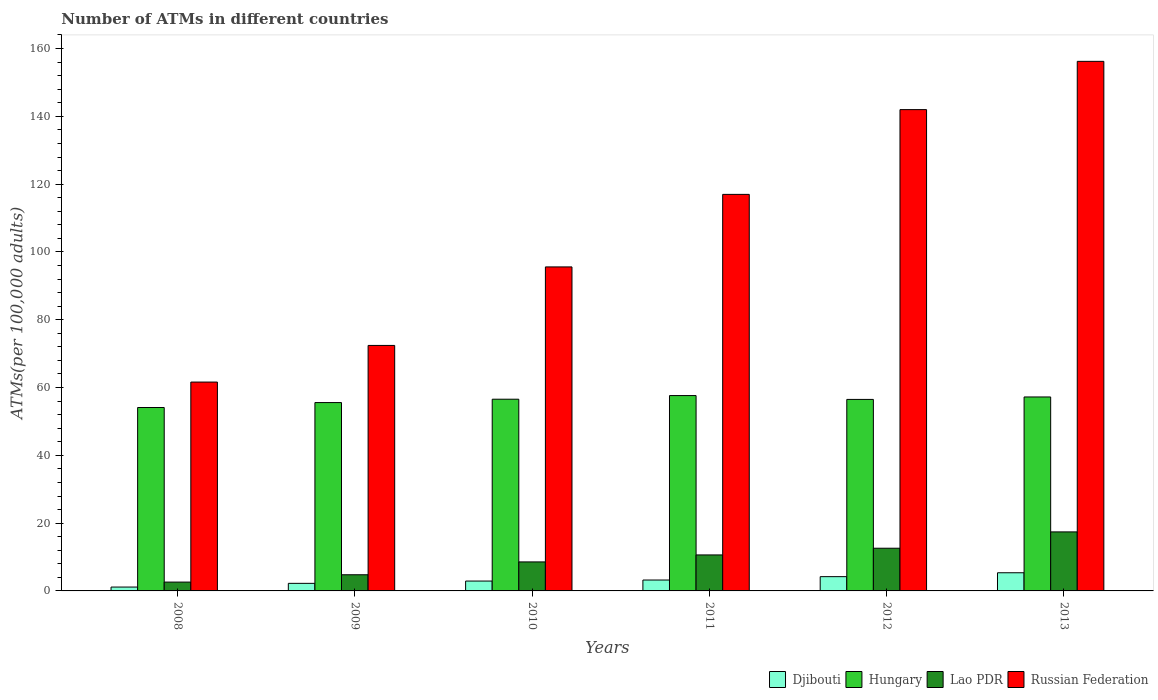How many different coloured bars are there?
Keep it short and to the point. 4. How many bars are there on the 6th tick from the left?
Your answer should be compact. 4. How many bars are there on the 4th tick from the right?
Your answer should be very brief. 4. What is the label of the 2nd group of bars from the left?
Your answer should be very brief. 2009. What is the number of ATMs in Lao PDR in 2011?
Your response must be concise. 10.62. Across all years, what is the maximum number of ATMs in Lao PDR?
Ensure brevity in your answer.  17.41. Across all years, what is the minimum number of ATMs in Hungary?
Ensure brevity in your answer.  54.1. In which year was the number of ATMs in Lao PDR maximum?
Make the answer very short. 2013. What is the total number of ATMs in Lao PDR in the graph?
Your response must be concise. 56.55. What is the difference between the number of ATMs in Russian Federation in 2009 and that in 2010?
Ensure brevity in your answer.  -23.16. What is the difference between the number of ATMs in Lao PDR in 2010 and the number of ATMs in Russian Federation in 2009?
Ensure brevity in your answer.  -63.86. What is the average number of ATMs in Hungary per year?
Make the answer very short. 56.26. In the year 2012, what is the difference between the number of ATMs in Lao PDR and number of ATMs in Russian Federation?
Offer a very short reply. -129.39. What is the ratio of the number of ATMs in Lao PDR in 2008 to that in 2009?
Give a very brief answer. 0.55. Is the difference between the number of ATMs in Lao PDR in 2010 and 2012 greater than the difference between the number of ATMs in Russian Federation in 2010 and 2012?
Make the answer very short. Yes. What is the difference between the highest and the second highest number of ATMs in Russian Federation?
Give a very brief answer. 14.24. What is the difference between the highest and the lowest number of ATMs in Lao PDR?
Provide a short and direct response. 14.8. In how many years, is the number of ATMs in Lao PDR greater than the average number of ATMs in Lao PDR taken over all years?
Provide a short and direct response. 3. Is the sum of the number of ATMs in Lao PDR in 2010 and 2011 greater than the maximum number of ATMs in Djibouti across all years?
Provide a short and direct response. Yes. Is it the case that in every year, the sum of the number of ATMs in Lao PDR and number of ATMs in Russian Federation is greater than the sum of number of ATMs in Djibouti and number of ATMs in Hungary?
Offer a very short reply. No. What does the 2nd bar from the left in 2011 represents?
Keep it short and to the point. Hungary. What does the 1st bar from the right in 2008 represents?
Make the answer very short. Russian Federation. How many bars are there?
Your answer should be compact. 24. How are the legend labels stacked?
Give a very brief answer. Horizontal. What is the title of the graph?
Your answer should be very brief. Number of ATMs in different countries. What is the label or title of the Y-axis?
Provide a short and direct response. ATMs(per 100,0 adults). What is the ATMs(per 100,000 adults) of Djibouti in 2008?
Ensure brevity in your answer.  1.14. What is the ATMs(per 100,000 adults) in Hungary in 2008?
Provide a succinct answer. 54.1. What is the ATMs(per 100,000 adults) in Lao PDR in 2008?
Keep it short and to the point. 2.61. What is the ATMs(per 100,000 adults) in Russian Federation in 2008?
Give a very brief answer. 61.61. What is the ATMs(per 100,000 adults) of Djibouti in 2009?
Provide a short and direct response. 2.23. What is the ATMs(per 100,000 adults) of Hungary in 2009?
Your answer should be very brief. 55.56. What is the ATMs(per 100,000 adults) of Lao PDR in 2009?
Provide a succinct answer. 4.77. What is the ATMs(per 100,000 adults) in Russian Federation in 2009?
Ensure brevity in your answer.  72.42. What is the ATMs(per 100,000 adults) of Djibouti in 2010?
Your response must be concise. 2.91. What is the ATMs(per 100,000 adults) of Hungary in 2010?
Keep it short and to the point. 56.55. What is the ATMs(per 100,000 adults) of Lao PDR in 2010?
Provide a short and direct response. 8.56. What is the ATMs(per 100,000 adults) in Russian Federation in 2010?
Offer a very short reply. 95.58. What is the ATMs(per 100,000 adults) of Djibouti in 2011?
Provide a short and direct response. 3.21. What is the ATMs(per 100,000 adults) of Hungary in 2011?
Provide a short and direct response. 57.63. What is the ATMs(per 100,000 adults) in Lao PDR in 2011?
Provide a succinct answer. 10.62. What is the ATMs(per 100,000 adults) in Russian Federation in 2011?
Make the answer very short. 116.98. What is the ATMs(per 100,000 adults) in Djibouti in 2012?
Provide a succinct answer. 4.21. What is the ATMs(per 100,000 adults) of Hungary in 2012?
Give a very brief answer. 56.49. What is the ATMs(per 100,000 adults) of Lao PDR in 2012?
Your answer should be very brief. 12.59. What is the ATMs(per 100,000 adults) in Russian Federation in 2012?
Offer a terse response. 141.98. What is the ATMs(per 100,000 adults) of Djibouti in 2013?
Your response must be concise. 5.36. What is the ATMs(per 100,000 adults) of Hungary in 2013?
Offer a terse response. 57.22. What is the ATMs(per 100,000 adults) in Lao PDR in 2013?
Make the answer very short. 17.41. What is the ATMs(per 100,000 adults) in Russian Federation in 2013?
Your answer should be compact. 156.22. Across all years, what is the maximum ATMs(per 100,000 adults) of Djibouti?
Keep it short and to the point. 5.36. Across all years, what is the maximum ATMs(per 100,000 adults) of Hungary?
Your answer should be compact. 57.63. Across all years, what is the maximum ATMs(per 100,000 adults) of Lao PDR?
Make the answer very short. 17.41. Across all years, what is the maximum ATMs(per 100,000 adults) of Russian Federation?
Give a very brief answer. 156.22. Across all years, what is the minimum ATMs(per 100,000 adults) in Djibouti?
Give a very brief answer. 1.14. Across all years, what is the minimum ATMs(per 100,000 adults) in Hungary?
Your answer should be very brief. 54.1. Across all years, what is the minimum ATMs(per 100,000 adults) in Lao PDR?
Your response must be concise. 2.61. Across all years, what is the minimum ATMs(per 100,000 adults) of Russian Federation?
Your answer should be compact. 61.61. What is the total ATMs(per 100,000 adults) in Djibouti in the graph?
Give a very brief answer. 19.07. What is the total ATMs(per 100,000 adults) of Hungary in the graph?
Make the answer very short. 337.55. What is the total ATMs(per 100,000 adults) of Lao PDR in the graph?
Your response must be concise. 56.55. What is the total ATMs(per 100,000 adults) of Russian Federation in the graph?
Keep it short and to the point. 644.78. What is the difference between the ATMs(per 100,000 adults) in Djibouti in 2008 and that in 2009?
Your answer should be very brief. -1.09. What is the difference between the ATMs(per 100,000 adults) of Hungary in 2008 and that in 2009?
Provide a succinct answer. -1.46. What is the difference between the ATMs(per 100,000 adults) in Lao PDR in 2008 and that in 2009?
Offer a terse response. -2.16. What is the difference between the ATMs(per 100,000 adults) of Russian Federation in 2008 and that in 2009?
Your response must be concise. -10.81. What is the difference between the ATMs(per 100,000 adults) in Djibouti in 2008 and that in 2010?
Keep it short and to the point. -1.77. What is the difference between the ATMs(per 100,000 adults) of Hungary in 2008 and that in 2010?
Your answer should be compact. -2.45. What is the difference between the ATMs(per 100,000 adults) of Lao PDR in 2008 and that in 2010?
Offer a very short reply. -5.95. What is the difference between the ATMs(per 100,000 adults) of Russian Federation in 2008 and that in 2010?
Make the answer very short. -33.97. What is the difference between the ATMs(per 100,000 adults) in Djibouti in 2008 and that in 2011?
Keep it short and to the point. -2.07. What is the difference between the ATMs(per 100,000 adults) of Hungary in 2008 and that in 2011?
Give a very brief answer. -3.52. What is the difference between the ATMs(per 100,000 adults) in Lao PDR in 2008 and that in 2011?
Provide a succinct answer. -8.01. What is the difference between the ATMs(per 100,000 adults) in Russian Federation in 2008 and that in 2011?
Provide a short and direct response. -55.36. What is the difference between the ATMs(per 100,000 adults) of Djibouti in 2008 and that in 2012?
Your response must be concise. -3.07. What is the difference between the ATMs(per 100,000 adults) of Hungary in 2008 and that in 2012?
Ensure brevity in your answer.  -2.39. What is the difference between the ATMs(per 100,000 adults) in Lao PDR in 2008 and that in 2012?
Ensure brevity in your answer.  -9.99. What is the difference between the ATMs(per 100,000 adults) of Russian Federation in 2008 and that in 2012?
Keep it short and to the point. -80.37. What is the difference between the ATMs(per 100,000 adults) of Djibouti in 2008 and that in 2013?
Keep it short and to the point. -4.22. What is the difference between the ATMs(per 100,000 adults) in Hungary in 2008 and that in 2013?
Ensure brevity in your answer.  -3.11. What is the difference between the ATMs(per 100,000 adults) of Lao PDR in 2008 and that in 2013?
Offer a very short reply. -14.8. What is the difference between the ATMs(per 100,000 adults) of Russian Federation in 2008 and that in 2013?
Ensure brevity in your answer.  -94.61. What is the difference between the ATMs(per 100,000 adults) of Djibouti in 2009 and that in 2010?
Give a very brief answer. -0.68. What is the difference between the ATMs(per 100,000 adults) in Hungary in 2009 and that in 2010?
Your response must be concise. -0.99. What is the difference between the ATMs(per 100,000 adults) in Lao PDR in 2009 and that in 2010?
Make the answer very short. -3.79. What is the difference between the ATMs(per 100,000 adults) of Russian Federation in 2009 and that in 2010?
Make the answer very short. -23.16. What is the difference between the ATMs(per 100,000 adults) in Djibouti in 2009 and that in 2011?
Your answer should be compact. -0.98. What is the difference between the ATMs(per 100,000 adults) of Hungary in 2009 and that in 2011?
Give a very brief answer. -2.07. What is the difference between the ATMs(per 100,000 adults) in Lao PDR in 2009 and that in 2011?
Provide a succinct answer. -5.85. What is the difference between the ATMs(per 100,000 adults) in Russian Federation in 2009 and that in 2011?
Provide a succinct answer. -44.56. What is the difference between the ATMs(per 100,000 adults) of Djibouti in 2009 and that in 2012?
Ensure brevity in your answer.  -1.98. What is the difference between the ATMs(per 100,000 adults) in Hungary in 2009 and that in 2012?
Make the answer very short. -0.93. What is the difference between the ATMs(per 100,000 adults) in Lao PDR in 2009 and that in 2012?
Your response must be concise. -7.83. What is the difference between the ATMs(per 100,000 adults) in Russian Federation in 2009 and that in 2012?
Offer a terse response. -69.56. What is the difference between the ATMs(per 100,000 adults) in Djibouti in 2009 and that in 2013?
Ensure brevity in your answer.  -3.13. What is the difference between the ATMs(per 100,000 adults) of Hungary in 2009 and that in 2013?
Offer a terse response. -1.66. What is the difference between the ATMs(per 100,000 adults) in Lao PDR in 2009 and that in 2013?
Make the answer very short. -12.64. What is the difference between the ATMs(per 100,000 adults) of Russian Federation in 2009 and that in 2013?
Make the answer very short. -83.8. What is the difference between the ATMs(per 100,000 adults) of Djibouti in 2010 and that in 2011?
Keep it short and to the point. -0.3. What is the difference between the ATMs(per 100,000 adults) in Hungary in 2010 and that in 2011?
Provide a short and direct response. -1.08. What is the difference between the ATMs(per 100,000 adults) in Lao PDR in 2010 and that in 2011?
Keep it short and to the point. -2.06. What is the difference between the ATMs(per 100,000 adults) in Russian Federation in 2010 and that in 2011?
Offer a very short reply. -21.4. What is the difference between the ATMs(per 100,000 adults) in Djibouti in 2010 and that in 2012?
Your response must be concise. -1.3. What is the difference between the ATMs(per 100,000 adults) in Hungary in 2010 and that in 2012?
Offer a very short reply. 0.06. What is the difference between the ATMs(per 100,000 adults) in Lao PDR in 2010 and that in 2012?
Keep it short and to the point. -4.04. What is the difference between the ATMs(per 100,000 adults) in Russian Federation in 2010 and that in 2012?
Provide a succinct answer. -46.4. What is the difference between the ATMs(per 100,000 adults) in Djibouti in 2010 and that in 2013?
Provide a short and direct response. -2.44. What is the difference between the ATMs(per 100,000 adults) in Hungary in 2010 and that in 2013?
Your answer should be compact. -0.67. What is the difference between the ATMs(per 100,000 adults) of Lao PDR in 2010 and that in 2013?
Your answer should be compact. -8.86. What is the difference between the ATMs(per 100,000 adults) in Russian Federation in 2010 and that in 2013?
Offer a terse response. -60.64. What is the difference between the ATMs(per 100,000 adults) in Djibouti in 2011 and that in 2012?
Provide a succinct answer. -1. What is the difference between the ATMs(per 100,000 adults) in Hungary in 2011 and that in 2012?
Your answer should be very brief. 1.13. What is the difference between the ATMs(per 100,000 adults) in Lao PDR in 2011 and that in 2012?
Your response must be concise. -1.98. What is the difference between the ATMs(per 100,000 adults) in Russian Federation in 2011 and that in 2012?
Ensure brevity in your answer.  -25.01. What is the difference between the ATMs(per 100,000 adults) in Djibouti in 2011 and that in 2013?
Make the answer very short. -2.14. What is the difference between the ATMs(per 100,000 adults) of Hungary in 2011 and that in 2013?
Your response must be concise. 0.41. What is the difference between the ATMs(per 100,000 adults) of Lao PDR in 2011 and that in 2013?
Ensure brevity in your answer.  -6.79. What is the difference between the ATMs(per 100,000 adults) in Russian Federation in 2011 and that in 2013?
Offer a very short reply. -39.24. What is the difference between the ATMs(per 100,000 adults) of Djibouti in 2012 and that in 2013?
Your response must be concise. -1.14. What is the difference between the ATMs(per 100,000 adults) in Hungary in 2012 and that in 2013?
Your answer should be compact. -0.72. What is the difference between the ATMs(per 100,000 adults) in Lao PDR in 2012 and that in 2013?
Provide a short and direct response. -4.82. What is the difference between the ATMs(per 100,000 adults) of Russian Federation in 2012 and that in 2013?
Keep it short and to the point. -14.24. What is the difference between the ATMs(per 100,000 adults) in Djibouti in 2008 and the ATMs(per 100,000 adults) in Hungary in 2009?
Ensure brevity in your answer.  -54.42. What is the difference between the ATMs(per 100,000 adults) of Djibouti in 2008 and the ATMs(per 100,000 adults) of Lao PDR in 2009?
Provide a short and direct response. -3.63. What is the difference between the ATMs(per 100,000 adults) of Djibouti in 2008 and the ATMs(per 100,000 adults) of Russian Federation in 2009?
Ensure brevity in your answer.  -71.28. What is the difference between the ATMs(per 100,000 adults) of Hungary in 2008 and the ATMs(per 100,000 adults) of Lao PDR in 2009?
Give a very brief answer. 49.34. What is the difference between the ATMs(per 100,000 adults) in Hungary in 2008 and the ATMs(per 100,000 adults) in Russian Federation in 2009?
Offer a terse response. -18.31. What is the difference between the ATMs(per 100,000 adults) of Lao PDR in 2008 and the ATMs(per 100,000 adults) of Russian Federation in 2009?
Offer a very short reply. -69.81. What is the difference between the ATMs(per 100,000 adults) of Djibouti in 2008 and the ATMs(per 100,000 adults) of Hungary in 2010?
Offer a very short reply. -55.41. What is the difference between the ATMs(per 100,000 adults) of Djibouti in 2008 and the ATMs(per 100,000 adults) of Lao PDR in 2010?
Your answer should be compact. -7.41. What is the difference between the ATMs(per 100,000 adults) of Djibouti in 2008 and the ATMs(per 100,000 adults) of Russian Federation in 2010?
Make the answer very short. -94.44. What is the difference between the ATMs(per 100,000 adults) in Hungary in 2008 and the ATMs(per 100,000 adults) in Lao PDR in 2010?
Your answer should be very brief. 45.55. What is the difference between the ATMs(per 100,000 adults) of Hungary in 2008 and the ATMs(per 100,000 adults) of Russian Federation in 2010?
Offer a very short reply. -41.47. What is the difference between the ATMs(per 100,000 adults) in Lao PDR in 2008 and the ATMs(per 100,000 adults) in Russian Federation in 2010?
Your answer should be very brief. -92.97. What is the difference between the ATMs(per 100,000 adults) of Djibouti in 2008 and the ATMs(per 100,000 adults) of Hungary in 2011?
Provide a succinct answer. -56.49. What is the difference between the ATMs(per 100,000 adults) of Djibouti in 2008 and the ATMs(per 100,000 adults) of Lao PDR in 2011?
Your answer should be very brief. -9.48. What is the difference between the ATMs(per 100,000 adults) of Djibouti in 2008 and the ATMs(per 100,000 adults) of Russian Federation in 2011?
Ensure brevity in your answer.  -115.83. What is the difference between the ATMs(per 100,000 adults) in Hungary in 2008 and the ATMs(per 100,000 adults) in Lao PDR in 2011?
Offer a terse response. 43.49. What is the difference between the ATMs(per 100,000 adults) of Hungary in 2008 and the ATMs(per 100,000 adults) of Russian Federation in 2011?
Offer a very short reply. -62.87. What is the difference between the ATMs(per 100,000 adults) of Lao PDR in 2008 and the ATMs(per 100,000 adults) of Russian Federation in 2011?
Make the answer very short. -114.37. What is the difference between the ATMs(per 100,000 adults) in Djibouti in 2008 and the ATMs(per 100,000 adults) in Hungary in 2012?
Give a very brief answer. -55.35. What is the difference between the ATMs(per 100,000 adults) of Djibouti in 2008 and the ATMs(per 100,000 adults) of Lao PDR in 2012?
Keep it short and to the point. -11.45. What is the difference between the ATMs(per 100,000 adults) in Djibouti in 2008 and the ATMs(per 100,000 adults) in Russian Federation in 2012?
Your answer should be very brief. -140.84. What is the difference between the ATMs(per 100,000 adults) in Hungary in 2008 and the ATMs(per 100,000 adults) in Lao PDR in 2012?
Make the answer very short. 41.51. What is the difference between the ATMs(per 100,000 adults) of Hungary in 2008 and the ATMs(per 100,000 adults) of Russian Federation in 2012?
Make the answer very short. -87.88. What is the difference between the ATMs(per 100,000 adults) of Lao PDR in 2008 and the ATMs(per 100,000 adults) of Russian Federation in 2012?
Offer a very short reply. -139.37. What is the difference between the ATMs(per 100,000 adults) of Djibouti in 2008 and the ATMs(per 100,000 adults) of Hungary in 2013?
Provide a succinct answer. -56.08. What is the difference between the ATMs(per 100,000 adults) of Djibouti in 2008 and the ATMs(per 100,000 adults) of Lao PDR in 2013?
Give a very brief answer. -16.27. What is the difference between the ATMs(per 100,000 adults) of Djibouti in 2008 and the ATMs(per 100,000 adults) of Russian Federation in 2013?
Provide a succinct answer. -155.08. What is the difference between the ATMs(per 100,000 adults) of Hungary in 2008 and the ATMs(per 100,000 adults) of Lao PDR in 2013?
Provide a short and direct response. 36.69. What is the difference between the ATMs(per 100,000 adults) in Hungary in 2008 and the ATMs(per 100,000 adults) in Russian Federation in 2013?
Ensure brevity in your answer.  -102.11. What is the difference between the ATMs(per 100,000 adults) in Lao PDR in 2008 and the ATMs(per 100,000 adults) in Russian Federation in 2013?
Provide a short and direct response. -153.61. What is the difference between the ATMs(per 100,000 adults) in Djibouti in 2009 and the ATMs(per 100,000 adults) in Hungary in 2010?
Keep it short and to the point. -54.32. What is the difference between the ATMs(per 100,000 adults) in Djibouti in 2009 and the ATMs(per 100,000 adults) in Lao PDR in 2010?
Offer a very short reply. -6.33. What is the difference between the ATMs(per 100,000 adults) of Djibouti in 2009 and the ATMs(per 100,000 adults) of Russian Federation in 2010?
Your answer should be very brief. -93.35. What is the difference between the ATMs(per 100,000 adults) of Hungary in 2009 and the ATMs(per 100,000 adults) of Lao PDR in 2010?
Provide a short and direct response. 47. What is the difference between the ATMs(per 100,000 adults) in Hungary in 2009 and the ATMs(per 100,000 adults) in Russian Federation in 2010?
Offer a terse response. -40.02. What is the difference between the ATMs(per 100,000 adults) in Lao PDR in 2009 and the ATMs(per 100,000 adults) in Russian Federation in 2010?
Make the answer very short. -90.81. What is the difference between the ATMs(per 100,000 adults) in Djibouti in 2009 and the ATMs(per 100,000 adults) in Hungary in 2011?
Give a very brief answer. -55.4. What is the difference between the ATMs(per 100,000 adults) in Djibouti in 2009 and the ATMs(per 100,000 adults) in Lao PDR in 2011?
Provide a succinct answer. -8.39. What is the difference between the ATMs(per 100,000 adults) in Djibouti in 2009 and the ATMs(per 100,000 adults) in Russian Federation in 2011?
Give a very brief answer. -114.75. What is the difference between the ATMs(per 100,000 adults) in Hungary in 2009 and the ATMs(per 100,000 adults) in Lao PDR in 2011?
Your answer should be very brief. 44.94. What is the difference between the ATMs(per 100,000 adults) in Hungary in 2009 and the ATMs(per 100,000 adults) in Russian Federation in 2011?
Provide a succinct answer. -61.42. What is the difference between the ATMs(per 100,000 adults) of Lao PDR in 2009 and the ATMs(per 100,000 adults) of Russian Federation in 2011?
Offer a very short reply. -112.21. What is the difference between the ATMs(per 100,000 adults) in Djibouti in 2009 and the ATMs(per 100,000 adults) in Hungary in 2012?
Your response must be concise. -54.26. What is the difference between the ATMs(per 100,000 adults) in Djibouti in 2009 and the ATMs(per 100,000 adults) in Lao PDR in 2012?
Offer a terse response. -10.36. What is the difference between the ATMs(per 100,000 adults) of Djibouti in 2009 and the ATMs(per 100,000 adults) of Russian Federation in 2012?
Make the answer very short. -139.75. What is the difference between the ATMs(per 100,000 adults) in Hungary in 2009 and the ATMs(per 100,000 adults) in Lao PDR in 2012?
Offer a terse response. 42.97. What is the difference between the ATMs(per 100,000 adults) in Hungary in 2009 and the ATMs(per 100,000 adults) in Russian Federation in 2012?
Your answer should be very brief. -86.42. What is the difference between the ATMs(per 100,000 adults) in Lao PDR in 2009 and the ATMs(per 100,000 adults) in Russian Federation in 2012?
Your response must be concise. -137.21. What is the difference between the ATMs(per 100,000 adults) of Djibouti in 2009 and the ATMs(per 100,000 adults) of Hungary in 2013?
Provide a short and direct response. -54.99. What is the difference between the ATMs(per 100,000 adults) in Djibouti in 2009 and the ATMs(per 100,000 adults) in Lao PDR in 2013?
Give a very brief answer. -15.18. What is the difference between the ATMs(per 100,000 adults) of Djibouti in 2009 and the ATMs(per 100,000 adults) of Russian Federation in 2013?
Give a very brief answer. -153.99. What is the difference between the ATMs(per 100,000 adults) of Hungary in 2009 and the ATMs(per 100,000 adults) of Lao PDR in 2013?
Offer a very short reply. 38.15. What is the difference between the ATMs(per 100,000 adults) of Hungary in 2009 and the ATMs(per 100,000 adults) of Russian Federation in 2013?
Offer a terse response. -100.66. What is the difference between the ATMs(per 100,000 adults) of Lao PDR in 2009 and the ATMs(per 100,000 adults) of Russian Federation in 2013?
Your answer should be very brief. -151.45. What is the difference between the ATMs(per 100,000 adults) of Djibouti in 2010 and the ATMs(per 100,000 adults) of Hungary in 2011?
Offer a very short reply. -54.71. What is the difference between the ATMs(per 100,000 adults) in Djibouti in 2010 and the ATMs(per 100,000 adults) in Lao PDR in 2011?
Give a very brief answer. -7.7. What is the difference between the ATMs(per 100,000 adults) in Djibouti in 2010 and the ATMs(per 100,000 adults) in Russian Federation in 2011?
Keep it short and to the point. -114.06. What is the difference between the ATMs(per 100,000 adults) in Hungary in 2010 and the ATMs(per 100,000 adults) in Lao PDR in 2011?
Provide a succinct answer. 45.93. What is the difference between the ATMs(per 100,000 adults) of Hungary in 2010 and the ATMs(per 100,000 adults) of Russian Federation in 2011?
Provide a succinct answer. -60.42. What is the difference between the ATMs(per 100,000 adults) of Lao PDR in 2010 and the ATMs(per 100,000 adults) of Russian Federation in 2011?
Your answer should be very brief. -108.42. What is the difference between the ATMs(per 100,000 adults) of Djibouti in 2010 and the ATMs(per 100,000 adults) of Hungary in 2012?
Your answer should be compact. -53.58. What is the difference between the ATMs(per 100,000 adults) in Djibouti in 2010 and the ATMs(per 100,000 adults) in Lao PDR in 2012?
Offer a very short reply. -9.68. What is the difference between the ATMs(per 100,000 adults) of Djibouti in 2010 and the ATMs(per 100,000 adults) of Russian Federation in 2012?
Offer a very short reply. -139.07. What is the difference between the ATMs(per 100,000 adults) in Hungary in 2010 and the ATMs(per 100,000 adults) in Lao PDR in 2012?
Offer a terse response. 43.96. What is the difference between the ATMs(per 100,000 adults) in Hungary in 2010 and the ATMs(per 100,000 adults) in Russian Federation in 2012?
Your answer should be compact. -85.43. What is the difference between the ATMs(per 100,000 adults) of Lao PDR in 2010 and the ATMs(per 100,000 adults) of Russian Federation in 2012?
Offer a terse response. -133.43. What is the difference between the ATMs(per 100,000 adults) in Djibouti in 2010 and the ATMs(per 100,000 adults) in Hungary in 2013?
Your answer should be compact. -54.3. What is the difference between the ATMs(per 100,000 adults) of Djibouti in 2010 and the ATMs(per 100,000 adults) of Lao PDR in 2013?
Provide a short and direct response. -14.5. What is the difference between the ATMs(per 100,000 adults) in Djibouti in 2010 and the ATMs(per 100,000 adults) in Russian Federation in 2013?
Ensure brevity in your answer.  -153.31. What is the difference between the ATMs(per 100,000 adults) in Hungary in 2010 and the ATMs(per 100,000 adults) in Lao PDR in 2013?
Provide a short and direct response. 39.14. What is the difference between the ATMs(per 100,000 adults) of Hungary in 2010 and the ATMs(per 100,000 adults) of Russian Federation in 2013?
Provide a succinct answer. -99.67. What is the difference between the ATMs(per 100,000 adults) in Lao PDR in 2010 and the ATMs(per 100,000 adults) in Russian Federation in 2013?
Offer a very short reply. -147.66. What is the difference between the ATMs(per 100,000 adults) of Djibouti in 2011 and the ATMs(per 100,000 adults) of Hungary in 2012?
Offer a very short reply. -53.28. What is the difference between the ATMs(per 100,000 adults) of Djibouti in 2011 and the ATMs(per 100,000 adults) of Lao PDR in 2012?
Offer a terse response. -9.38. What is the difference between the ATMs(per 100,000 adults) in Djibouti in 2011 and the ATMs(per 100,000 adults) in Russian Federation in 2012?
Keep it short and to the point. -138.77. What is the difference between the ATMs(per 100,000 adults) of Hungary in 2011 and the ATMs(per 100,000 adults) of Lao PDR in 2012?
Provide a short and direct response. 45.03. What is the difference between the ATMs(per 100,000 adults) in Hungary in 2011 and the ATMs(per 100,000 adults) in Russian Federation in 2012?
Provide a short and direct response. -84.35. What is the difference between the ATMs(per 100,000 adults) in Lao PDR in 2011 and the ATMs(per 100,000 adults) in Russian Federation in 2012?
Make the answer very short. -131.36. What is the difference between the ATMs(per 100,000 adults) in Djibouti in 2011 and the ATMs(per 100,000 adults) in Hungary in 2013?
Ensure brevity in your answer.  -54. What is the difference between the ATMs(per 100,000 adults) in Djibouti in 2011 and the ATMs(per 100,000 adults) in Lao PDR in 2013?
Your answer should be compact. -14.2. What is the difference between the ATMs(per 100,000 adults) of Djibouti in 2011 and the ATMs(per 100,000 adults) of Russian Federation in 2013?
Offer a terse response. -153. What is the difference between the ATMs(per 100,000 adults) in Hungary in 2011 and the ATMs(per 100,000 adults) in Lao PDR in 2013?
Provide a short and direct response. 40.22. What is the difference between the ATMs(per 100,000 adults) in Hungary in 2011 and the ATMs(per 100,000 adults) in Russian Federation in 2013?
Offer a terse response. -98.59. What is the difference between the ATMs(per 100,000 adults) in Lao PDR in 2011 and the ATMs(per 100,000 adults) in Russian Federation in 2013?
Give a very brief answer. -145.6. What is the difference between the ATMs(per 100,000 adults) of Djibouti in 2012 and the ATMs(per 100,000 adults) of Hungary in 2013?
Offer a very short reply. -53. What is the difference between the ATMs(per 100,000 adults) of Djibouti in 2012 and the ATMs(per 100,000 adults) of Lao PDR in 2013?
Your answer should be compact. -13.2. What is the difference between the ATMs(per 100,000 adults) of Djibouti in 2012 and the ATMs(per 100,000 adults) of Russian Federation in 2013?
Your response must be concise. -152.01. What is the difference between the ATMs(per 100,000 adults) in Hungary in 2012 and the ATMs(per 100,000 adults) in Lao PDR in 2013?
Provide a short and direct response. 39.08. What is the difference between the ATMs(per 100,000 adults) in Hungary in 2012 and the ATMs(per 100,000 adults) in Russian Federation in 2013?
Make the answer very short. -99.72. What is the difference between the ATMs(per 100,000 adults) in Lao PDR in 2012 and the ATMs(per 100,000 adults) in Russian Federation in 2013?
Give a very brief answer. -143.62. What is the average ATMs(per 100,000 adults) in Djibouti per year?
Keep it short and to the point. 3.18. What is the average ATMs(per 100,000 adults) in Hungary per year?
Offer a terse response. 56.26. What is the average ATMs(per 100,000 adults) in Lao PDR per year?
Your answer should be compact. 9.43. What is the average ATMs(per 100,000 adults) of Russian Federation per year?
Provide a short and direct response. 107.46. In the year 2008, what is the difference between the ATMs(per 100,000 adults) of Djibouti and ATMs(per 100,000 adults) of Hungary?
Provide a succinct answer. -52.96. In the year 2008, what is the difference between the ATMs(per 100,000 adults) in Djibouti and ATMs(per 100,000 adults) in Lao PDR?
Offer a very short reply. -1.47. In the year 2008, what is the difference between the ATMs(per 100,000 adults) of Djibouti and ATMs(per 100,000 adults) of Russian Federation?
Your answer should be compact. -60.47. In the year 2008, what is the difference between the ATMs(per 100,000 adults) of Hungary and ATMs(per 100,000 adults) of Lao PDR?
Give a very brief answer. 51.5. In the year 2008, what is the difference between the ATMs(per 100,000 adults) in Hungary and ATMs(per 100,000 adults) in Russian Federation?
Your answer should be compact. -7.51. In the year 2008, what is the difference between the ATMs(per 100,000 adults) of Lao PDR and ATMs(per 100,000 adults) of Russian Federation?
Ensure brevity in your answer.  -59. In the year 2009, what is the difference between the ATMs(per 100,000 adults) of Djibouti and ATMs(per 100,000 adults) of Hungary?
Provide a short and direct response. -53.33. In the year 2009, what is the difference between the ATMs(per 100,000 adults) of Djibouti and ATMs(per 100,000 adults) of Lao PDR?
Your answer should be very brief. -2.54. In the year 2009, what is the difference between the ATMs(per 100,000 adults) in Djibouti and ATMs(per 100,000 adults) in Russian Federation?
Your answer should be compact. -70.19. In the year 2009, what is the difference between the ATMs(per 100,000 adults) in Hungary and ATMs(per 100,000 adults) in Lao PDR?
Provide a succinct answer. 50.79. In the year 2009, what is the difference between the ATMs(per 100,000 adults) in Hungary and ATMs(per 100,000 adults) in Russian Federation?
Provide a succinct answer. -16.86. In the year 2009, what is the difference between the ATMs(per 100,000 adults) of Lao PDR and ATMs(per 100,000 adults) of Russian Federation?
Ensure brevity in your answer.  -67.65. In the year 2010, what is the difference between the ATMs(per 100,000 adults) in Djibouti and ATMs(per 100,000 adults) in Hungary?
Offer a terse response. -53.64. In the year 2010, what is the difference between the ATMs(per 100,000 adults) in Djibouti and ATMs(per 100,000 adults) in Lao PDR?
Your answer should be compact. -5.64. In the year 2010, what is the difference between the ATMs(per 100,000 adults) in Djibouti and ATMs(per 100,000 adults) in Russian Federation?
Ensure brevity in your answer.  -92.67. In the year 2010, what is the difference between the ATMs(per 100,000 adults) of Hungary and ATMs(per 100,000 adults) of Lao PDR?
Ensure brevity in your answer.  48. In the year 2010, what is the difference between the ATMs(per 100,000 adults) of Hungary and ATMs(per 100,000 adults) of Russian Federation?
Make the answer very short. -39.03. In the year 2010, what is the difference between the ATMs(per 100,000 adults) in Lao PDR and ATMs(per 100,000 adults) in Russian Federation?
Your response must be concise. -87.02. In the year 2011, what is the difference between the ATMs(per 100,000 adults) in Djibouti and ATMs(per 100,000 adults) in Hungary?
Ensure brevity in your answer.  -54.41. In the year 2011, what is the difference between the ATMs(per 100,000 adults) in Djibouti and ATMs(per 100,000 adults) in Lao PDR?
Ensure brevity in your answer.  -7.4. In the year 2011, what is the difference between the ATMs(per 100,000 adults) of Djibouti and ATMs(per 100,000 adults) of Russian Federation?
Your answer should be compact. -113.76. In the year 2011, what is the difference between the ATMs(per 100,000 adults) in Hungary and ATMs(per 100,000 adults) in Lao PDR?
Your answer should be very brief. 47.01. In the year 2011, what is the difference between the ATMs(per 100,000 adults) of Hungary and ATMs(per 100,000 adults) of Russian Federation?
Provide a short and direct response. -59.35. In the year 2011, what is the difference between the ATMs(per 100,000 adults) of Lao PDR and ATMs(per 100,000 adults) of Russian Federation?
Provide a short and direct response. -106.36. In the year 2012, what is the difference between the ATMs(per 100,000 adults) in Djibouti and ATMs(per 100,000 adults) in Hungary?
Your response must be concise. -52.28. In the year 2012, what is the difference between the ATMs(per 100,000 adults) of Djibouti and ATMs(per 100,000 adults) of Lao PDR?
Ensure brevity in your answer.  -8.38. In the year 2012, what is the difference between the ATMs(per 100,000 adults) in Djibouti and ATMs(per 100,000 adults) in Russian Federation?
Provide a short and direct response. -137.77. In the year 2012, what is the difference between the ATMs(per 100,000 adults) in Hungary and ATMs(per 100,000 adults) in Lao PDR?
Provide a succinct answer. 43.9. In the year 2012, what is the difference between the ATMs(per 100,000 adults) in Hungary and ATMs(per 100,000 adults) in Russian Federation?
Keep it short and to the point. -85.49. In the year 2012, what is the difference between the ATMs(per 100,000 adults) in Lao PDR and ATMs(per 100,000 adults) in Russian Federation?
Offer a very short reply. -129.39. In the year 2013, what is the difference between the ATMs(per 100,000 adults) of Djibouti and ATMs(per 100,000 adults) of Hungary?
Offer a very short reply. -51.86. In the year 2013, what is the difference between the ATMs(per 100,000 adults) in Djibouti and ATMs(per 100,000 adults) in Lao PDR?
Your answer should be compact. -12.05. In the year 2013, what is the difference between the ATMs(per 100,000 adults) in Djibouti and ATMs(per 100,000 adults) in Russian Federation?
Offer a very short reply. -150.86. In the year 2013, what is the difference between the ATMs(per 100,000 adults) in Hungary and ATMs(per 100,000 adults) in Lao PDR?
Provide a short and direct response. 39.81. In the year 2013, what is the difference between the ATMs(per 100,000 adults) of Hungary and ATMs(per 100,000 adults) of Russian Federation?
Offer a very short reply. -99. In the year 2013, what is the difference between the ATMs(per 100,000 adults) of Lao PDR and ATMs(per 100,000 adults) of Russian Federation?
Provide a succinct answer. -138.81. What is the ratio of the ATMs(per 100,000 adults) of Djibouti in 2008 to that in 2009?
Make the answer very short. 0.51. What is the ratio of the ATMs(per 100,000 adults) in Hungary in 2008 to that in 2009?
Make the answer very short. 0.97. What is the ratio of the ATMs(per 100,000 adults) of Lao PDR in 2008 to that in 2009?
Provide a succinct answer. 0.55. What is the ratio of the ATMs(per 100,000 adults) of Russian Federation in 2008 to that in 2009?
Ensure brevity in your answer.  0.85. What is the ratio of the ATMs(per 100,000 adults) in Djibouti in 2008 to that in 2010?
Your answer should be compact. 0.39. What is the ratio of the ATMs(per 100,000 adults) of Hungary in 2008 to that in 2010?
Your answer should be very brief. 0.96. What is the ratio of the ATMs(per 100,000 adults) of Lao PDR in 2008 to that in 2010?
Offer a very short reply. 0.3. What is the ratio of the ATMs(per 100,000 adults) of Russian Federation in 2008 to that in 2010?
Your answer should be compact. 0.64. What is the ratio of the ATMs(per 100,000 adults) in Djibouti in 2008 to that in 2011?
Your answer should be compact. 0.35. What is the ratio of the ATMs(per 100,000 adults) of Hungary in 2008 to that in 2011?
Provide a short and direct response. 0.94. What is the ratio of the ATMs(per 100,000 adults) of Lao PDR in 2008 to that in 2011?
Provide a succinct answer. 0.25. What is the ratio of the ATMs(per 100,000 adults) of Russian Federation in 2008 to that in 2011?
Keep it short and to the point. 0.53. What is the ratio of the ATMs(per 100,000 adults) in Djibouti in 2008 to that in 2012?
Offer a terse response. 0.27. What is the ratio of the ATMs(per 100,000 adults) of Hungary in 2008 to that in 2012?
Your answer should be very brief. 0.96. What is the ratio of the ATMs(per 100,000 adults) of Lao PDR in 2008 to that in 2012?
Offer a terse response. 0.21. What is the ratio of the ATMs(per 100,000 adults) of Russian Federation in 2008 to that in 2012?
Your answer should be compact. 0.43. What is the ratio of the ATMs(per 100,000 adults) of Djibouti in 2008 to that in 2013?
Make the answer very short. 0.21. What is the ratio of the ATMs(per 100,000 adults) of Hungary in 2008 to that in 2013?
Your answer should be very brief. 0.95. What is the ratio of the ATMs(per 100,000 adults) of Lao PDR in 2008 to that in 2013?
Ensure brevity in your answer.  0.15. What is the ratio of the ATMs(per 100,000 adults) in Russian Federation in 2008 to that in 2013?
Your answer should be compact. 0.39. What is the ratio of the ATMs(per 100,000 adults) of Djibouti in 2009 to that in 2010?
Provide a short and direct response. 0.77. What is the ratio of the ATMs(per 100,000 adults) in Hungary in 2009 to that in 2010?
Give a very brief answer. 0.98. What is the ratio of the ATMs(per 100,000 adults) of Lao PDR in 2009 to that in 2010?
Offer a terse response. 0.56. What is the ratio of the ATMs(per 100,000 adults) of Russian Federation in 2009 to that in 2010?
Provide a short and direct response. 0.76. What is the ratio of the ATMs(per 100,000 adults) in Djibouti in 2009 to that in 2011?
Your answer should be very brief. 0.69. What is the ratio of the ATMs(per 100,000 adults) of Hungary in 2009 to that in 2011?
Your answer should be compact. 0.96. What is the ratio of the ATMs(per 100,000 adults) of Lao PDR in 2009 to that in 2011?
Ensure brevity in your answer.  0.45. What is the ratio of the ATMs(per 100,000 adults) in Russian Federation in 2009 to that in 2011?
Provide a succinct answer. 0.62. What is the ratio of the ATMs(per 100,000 adults) of Djibouti in 2009 to that in 2012?
Your answer should be very brief. 0.53. What is the ratio of the ATMs(per 100,000 adults) in Hungary in 2009 to that in 2012?
Your answer should be compact. 0.98. What is the ratio of the ATMs(per 100,000 adults) in Lao PDR in 2009 to that in 2012?
Offer a very short reply. 0.38. What is the ratio of the ATMs(per 100,000 adults) of Russian Federation in 2009 to that in 2012?
Keep it short and to the point. 0.51. What is the ratio of the ATMs(per 100,000 adults) of Djibouti in 2009 to that in 2013?
Your answer should be compact. 0.42. What is the ratio of the ATMs(per 100,000 adults) of Hungary in 2009 to that in 2013?
Provide a succinct answer. 0.97. What is the ratio of the ATMs(per 100,000 adults) of Lao PDR in 2009 to that in 2013?
Ensure brevity in your answer.  0.27. What is the ratio of the ATMs(per 100,000 adults) of Russian Federation in 2009 to that in 2013?
Offer a very short reply. 0.46. What is the ratio of the ATMs(per 100,000 adults) of Djibouti in 2010 to that in 2011?
Give a very brief answer. 0.91. What is the ratio of the ATMs(per 100,000 adults) in Hungary in 2010 to that in 2011?
Keep it short and to the point. 0.98. What is the ratio of the ATMs(per 100,000 adults) in Lao PDR in 2010 to that in 2011?
Your answer should be very brief. 0.81. What is the ratio of the ATMs(per 100,000 adults) in Russian Federation in 2010 to that in 2011?
Provide a short and direct response. 0.82. What is the ratio of the ATMs(per 100,000 adults) of Djibouti in 2010 to that in 2012?
Give a very brief answer. 0.69. What is the ratio of the ATMs(per 100,000 adults) of Hungary in 2010 to that in 2012?
Offer a terse response. 1. What is the ratio of the ATMs(per 100,000 adults) in Lao PDR in 2010 to that in 2012?
Make the answer very short. 0.68. What is the ratio of the ATMs(per 100,000 adults) in Russian Federation in 2010 to that in 2012?
Provide a succinct answer. 0.67. What is the ratio of the ATMs(per 100,000 adults) of Djibouti in 2010 to that in 2013?
Keep it short and to the point. 0.54. What is the ratio of the ATMs(per 100,000 adults) of Hungary in 2010 to that in 2013?
Ensure brevity in your answer.  0.99. What is the ratio of the ATMs(per 100,000 adults) of Lao PDR in 2010 to that in 2013?
Give a very brief answer. 0.49. What is the ratio of the ATMs(per 100,000 adults) of Russian Federation in 2010 to that in 2013?
Provide a succinct answer. 0.61. What is the ratio of the ATMs(per 100,000 adults) of Djibouti in 2011 to that in 2012?
Your answer should be compact. 0.76. What is the ratio of the ATMs(per 100,000 adults) of Hungary in 2011 to that in 2012?
Ensure brevity in your answer.  1.02. What is the ratio of the ATMs(per 100,000 adults) of Lao PDR in 2011 to that in 2012?
Your answer should be very brief. 0.84. What is the ratio of the ATMs(per 100,000 adults) in Russian Federation in 2011 to that in 2012?
Your response must be concise. 0.82. What is the ratio of the ATMs(per 100,000 adults) of Djibouti in 2011 to that in 2013?
Your answer should be compact. 0.6. What is the ratio of the ATMs(per 100,000 adults) in Lao PDR in 2011 to that in 2013?
Your answer should be very brief. 0.61. What is the ratio of the ATMs(per 100,000 adults) in Russian Federation in 2011 to that in 2013?
Offer a very short reply. 0.75. What is the ratio of the ATMs(per 100,000 adults) in Djibouti in 2012 to that in 2013?
Ensure brevity in your answer.  0.79. What is the ratio of the ATMs(per 100,000 adults) in Hungary in 2012 to that in 2013?
Provide a short and direct response. 0.99. What is the ratio of the ATMs(per 100,000 adults) in Lao PDR in 2012 to that in 2013?
Ensure brevity in your answer.  0.72. What is the ratio of the ATMs(per 100,000 adults) in Russian Federation in 2012 to that in 2013?
Your response must be concise. 0.91. What is the difference between the highest and the second highest ATMs(per 100,000 adults) in Djibouti?
Offer a very short reply. 1.14. What is the difference between the highest and the second highest ATMs(per 100,000 adults) of Hungary?
Make the answer very short. 0.41. What is the difference between the highest and the second highest ATMs(per 100,000 adults) in Lao PDR?
Ensure brevity in your answer.  4.82. What is the difference between the highest and the second highest ATMs(per 100,000 adults) of Russian Federation?
Provide a short and direct response. 14.24. What is the difference between the highest and the lowest ATMs(per 100,000 adults) in Djibouti?
Provide a succinct answer. 4.22. What is the difference between the highest and the lowest ATMs(per 100,000 adults) of Hungary?
Offer a terse response. 3.52. What is the difference between the highest and the lowest ATMs(per 100,000 adults) in Lao PDR?
Provide a succinct answer. 14.8. What is the difference between the highest and the lowest ATMs(per 100,000 adults) in Russian Federation?
Provide a succinct answer. 94.61. 